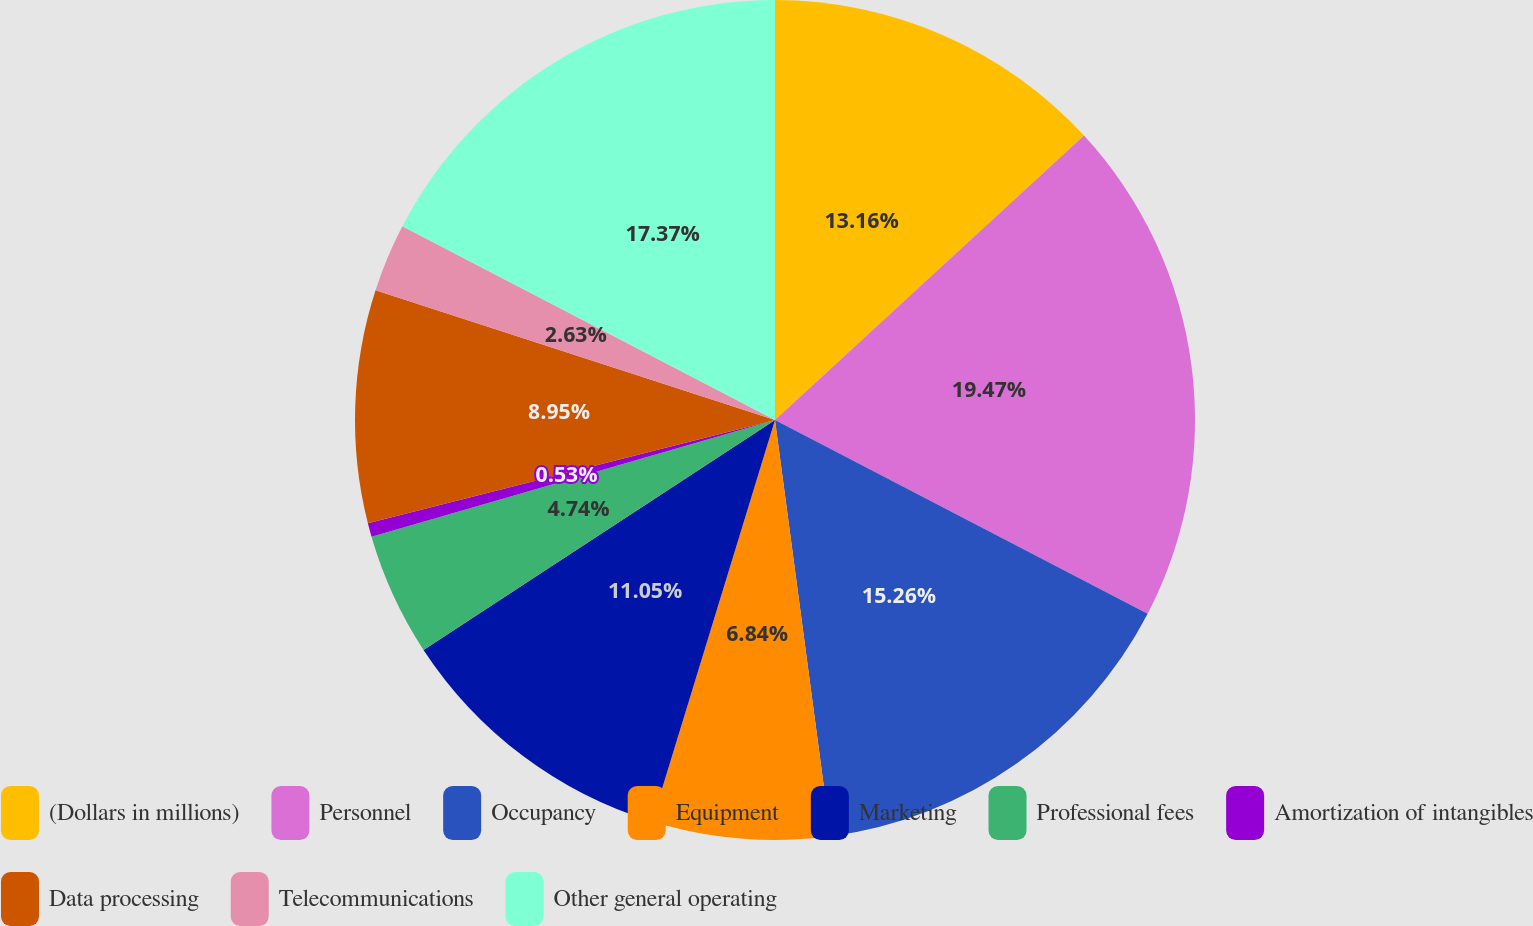Convert chart to OTSL. <chart><loc_0><loc_0><loc_500><loc_500><pie_chart><fcel>(Dollars in millions)<fcel>Personnel<fcel>Occupancy<fcel>Equipment<fcel>Marketing<fcel>Professional fees<fcel>Amortization of intangibles<fcel>Data processing<fcel>Telecommunications<fcel>Other general operating<nl><fcel>13.16%<fcel>19.47%<fcel>15.26%<fcel>6.84%<fcel>11.05%<fcel>4.74%<fcel>0.53%<fcel>8.95%<fcel>2.63%<fcel>17.37%<nl></chart> 